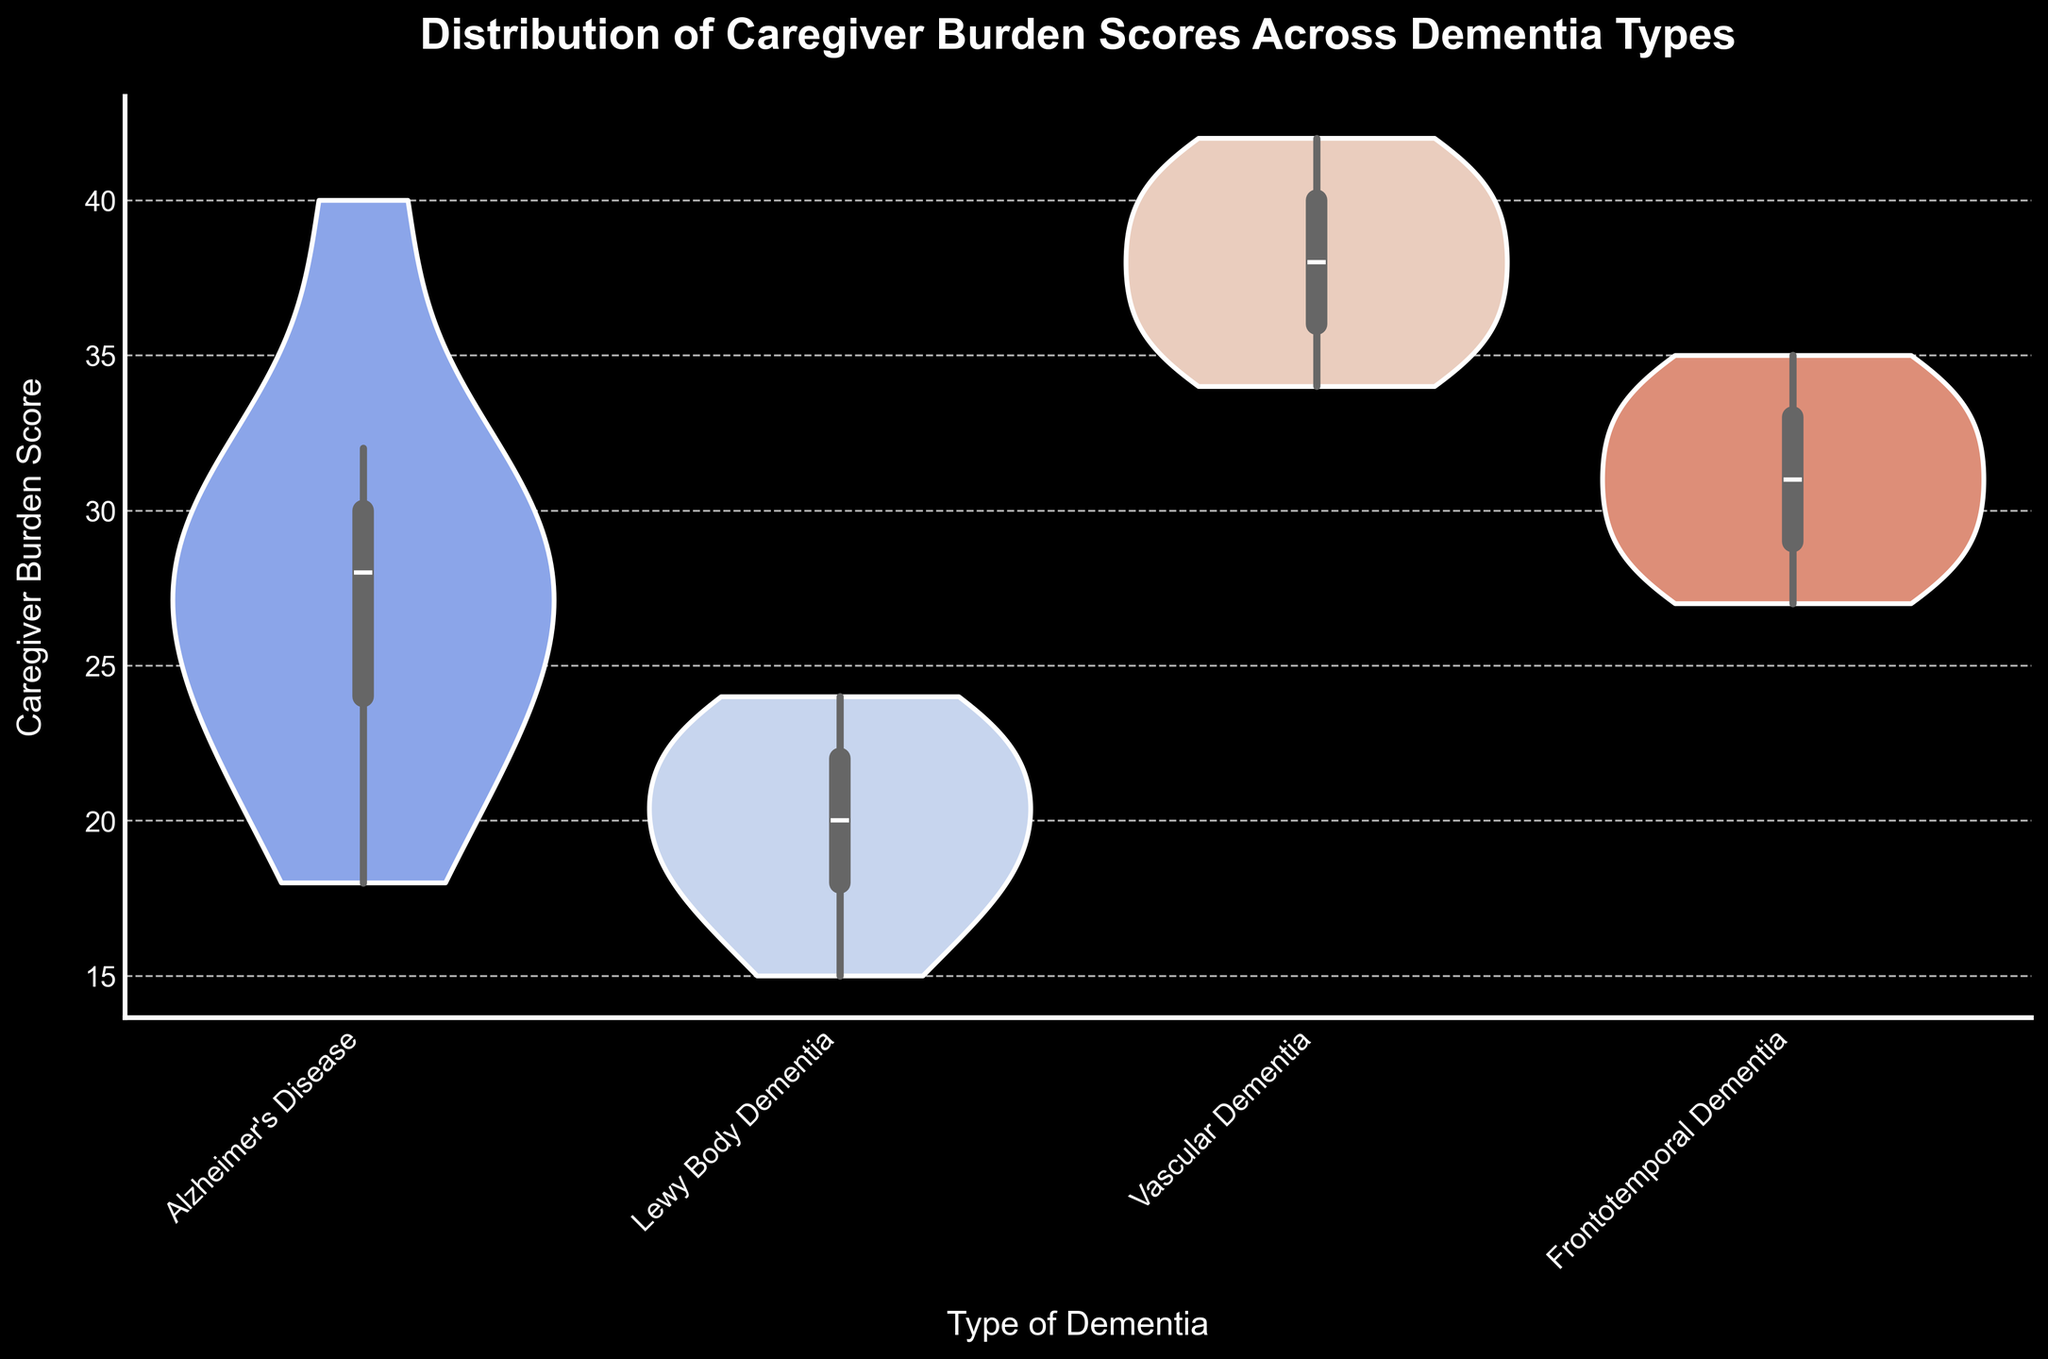What is the title of the figure? The title is usually displayed at the top of the figure. The title here reads "Distribution of Caregiver Burden Scores Across Dementia Types."
Answer: Distribution of Caregiver Burden Scores Across Dementia Types What does the x-axis represent? The axes are usually labeled. The x-axis in the figure is labeled "Type of Dementia."
Answer: Type of Dementia Which dementia type has the widest range of caregiver burden scores? The width of the violin plot indicates the range of the scores. Vascular Dementia has the widest spread of scores.
Answer: Vascular Dementia Between Alzheimer's Disease and Lewy Body Dementia, which one has a higher median caregiver burden score? The median is shown by the thick line in the center of the violin plots. Alzheimer's Disease has a higher median score than Lewy Body Dementia.
Answer: Alzheimer's Disease Do any dementia types have overlap in their caregiver burden scores? Overlap can be seen where violin plots extend into similar ranges. Alzheimer's Disease and Frontotemporal Dementia have overlapping score ranges.
Answer: Yes Which dementia type seems to be the most challenging for caregivers based on the median score? The most challenging type has the highest median score. Vascular Dementia has the highest median score.
Answer: Vascular Dementia What is the approximate maximum caregiver burden score for Frontotemporal Dementia? The maximum score is the top boundary of the widest part of the violin plot for each dementia type. For Frontotemporal Dementia, the approximate maximum caregiver burden score is 35.
Answer: Approximately 35 How does the variability of caregiver burden scores compare between Alzheimer's Disease and Frontotemporal Dementia? Variability can be inferred from the width and spread of the violin plots. Alzheimer's Disease shows more variability compared to Frontotemporal Dementia.
Answer: Alzheimer's Disease has more variability What is the approximate minimum caregiver burden score for Lewy Body Dementia? The minimum score is the bottom boundary of the widest part of the violin plot. For Lewy Body Dementia, it is approximately 15.
Answer: Approximately 15 Are the inner details of the violin plots shown in the figure? The description mentions that inner details are visible, indicated by 'inner='box.'' This suggests boxplots within the violins.
Answer: Yes 